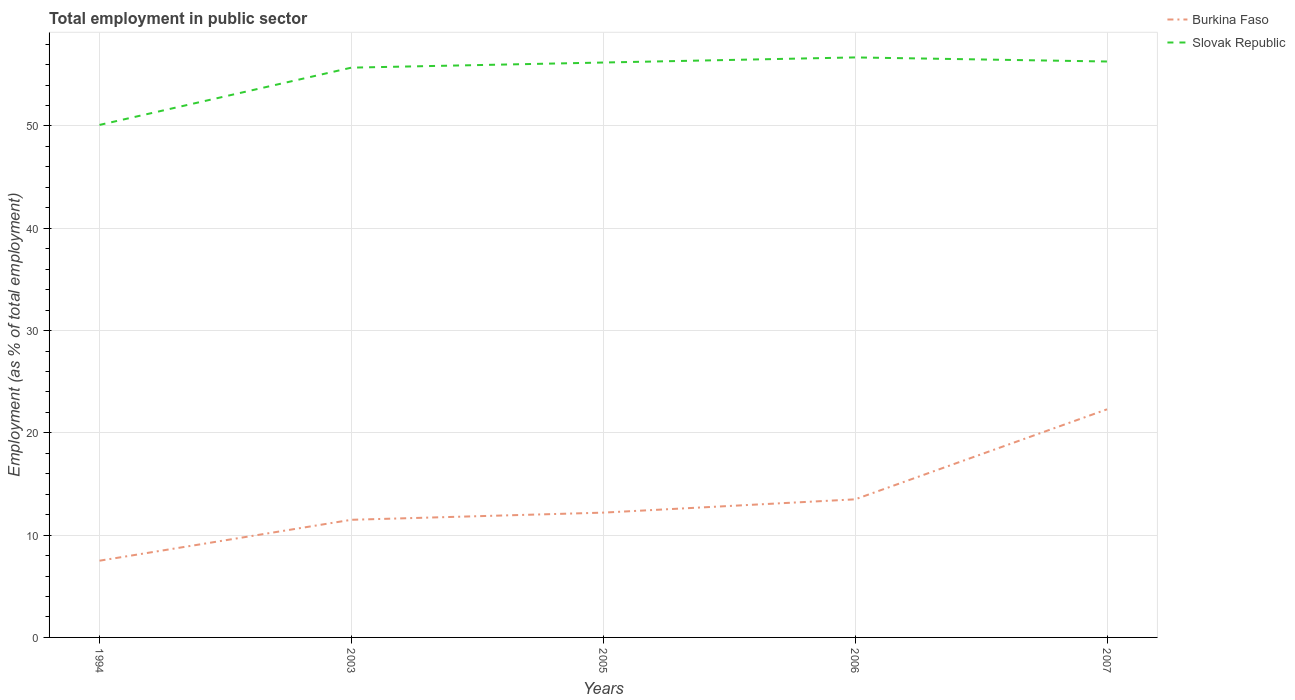Is the number of lines equal to the number of legend labels?
Your answer should be very brief. Yes. Across all years, what is the maximum employment in public sector in Burkina Faso?
Make the answer very short. 7.5. In which year was the employment in public sector in Slovak Republic maximum?
Your answer should be compact. 1994. What is the total employment in public sector in Slovak Republic in the graph?
Your answer should be compact. -0.5. What is the difference between the highest and the second highest employment in public sector in Slovak Republic?
Make the answer very short. 6.6. How many years are there in the graph?
Offer a very short reply. 5. What is the difference between two consecutive major ticks on the Y-axis?
Offer a terse response. 10. Does the graph contain any zero values?
Ensure brevity in your answer.  No. Where does the legend appear in the graph?
Your answer should be very brief. Top right. How many legend labels are there?
Make the answer very short. 2. How are the legend labels stacked?
Offer a terse response. Vertical. What is the title of the graph?
Your answer should be compact. Total employment in public sector. Does "Switzerland" appear as one of the legend labels in the graph?
Ensure brevity in your answer.  No. What is the label or title of the Y-axis?
Offer a terse response. Employment (as % of total employment). What is the Employment (as % of total employment) in Slovak Republic in 1994?
Keep it short and to the point. 50.1. What is the Employment (as % of total employment) of Slovak Republic in 2003?
Give a very brief answer. 55.7. What is the Employment (as % of total employment) in Burkina Faso in 2005?
Provide a succinct answer. 12.2. What is the Employment (as % of total employment) of Slovak Republic in 2005?
Offer a terse response. 56.2. What is the Employment (as % of total employment) in Burkina Faso in 2006?
Your response must be concise. 13.5. What is the Employment (as % of total employment) of Slovak Republic in 2006?
Give a very brief answer. 56.7. What is the Employment (as % of total employment) in Burkina Faso in 2007?
Offer a terse response. 22.3. What is the Employment (as % of total employment) in Slovak Republic in 2007?
Ensure brevity in your answer.  56.3. Across all years, what is the maximum Employment (as % of total employment) in Burkina Faso?
Give a very brief answer. 22.3. Across all years, what is the maximum Employment (as % of total employment) in Slovak Republic?
Make the answer very short. 56.7. Across all years, what is the minimum Employment (as % of total employment) of Burkina Faso?
Provide a succinct answer. 7.5. Across all years, what is the minimum Employment (as % of total employment) in Slovak Republic?
Your response must be concise. 50.1. What is the total Employment (as % of total employment) of Burkina Faso in the graph?
Make the answer very short. 67. What is the total Employment (as % of total employment) in Slovak Republic in the graph?
Provide a succinct answer. 275. What is the difference between the Employment (as % of total employment) in Burkina Faso in 1994 and that in 2003?
Offer a very short reply. -4. What is the difference between the Employment (as % of total employment) of Slovak Republic in 1994 and that in 2003?
Ensure brevity in your answer.  -5.6. What is the difference between the Employment (as % of total employment) of Burkina Faso in 1994 and that in 2006?
Make the answer very short. -6. What is the difference between the Employment (as % of total employment) of Slovak Republic in 1994 and that in 2006?
Make the answer very short. -6.6. What is the difference between the Employment (as % of total employment) in Burkina Faso in 1994 and that in 2007?
Provide a short and direct response. -14.8. What is the difference between the Employment (as % of total employment) of Burkina Faso in 2003 and that in 2006?
Give a very brief answer. -2. What is the difference between the Employment (as % of total employment) of Slovak Republic in 2003 and that in 2006?
Ensure brevity in your answer.  -1. What is the difference between the Employment (as % of total employment) of Burkina Faso in 2005 and that in 2007?
Offer a terse response. -10.1. What is the difference between the Employment (as % of total employment) in Slovak Republic in 2005 and that in 2007?
Give a very brief answer. -0.1. What is the difference between the Employment (as % of total employment) of Slovak Republic in 2006 and that in 2007?
Keep it short and to the point. 0.4. What is the difference between the Employment (as % of total employment) of Burkina Faso in 1994 and the Employment (as % of total employment) of Slovak Republic in 2003?
Your response must be concise. -48.2. What is the difference between the Employment (as % of total employment) of Burkina Faso in 1994 and the Employment (as % of total employment) of Slovak Republic in 2005?
Your answer should be very brief. -48.7. What is the difference between the Employment (as % of total employment) in Burkina Faso in 1994 and the Employment (as % of total employment) in Slovak Republic in 2006?
Your answer should be compact. -49.2. What is the difference between the Employment (as % of total employment) of Burkina Faso in 1994 and the Employment (as % of total employment) of Slovak Republic in 2007?
Your response must be concise. -48.8. What is the difference between the Employment (as % of total employment) of Burkina Faso in 2003 and the Employment (as % of total employment) of Slovak Republic in 2005?
Offer a very short reply. -44.7. What is the difference between the Employment (as % of total employment) in Burkina Faso in 2003 and the Employment (as % of total employment) in Slovak Republic in 2006?
Your answer should be very brief. -45.2. What is the difference between the Employment (as % of total employment) in Burkina Faso in 2003 and the Employment (as % of total employment) in Slovak Republic in 2007?
Provide a succinct answer. -44.8. What is the difference between the Employment (as % of total employment) in Burkina Faso in 2005 and the Employment (as % of total employment) in Slovak Republic in 2006?
Keep it short and to the point. -44.5. What is the difference between the Employment (as % of total employment) in Burkina Faso in 2005 and the Employment (as % of total employment) in Slovak Republic in 2007?
Provide a succinct answer. -44.1. What is the difference between the Employment (as % of total employment) of Burkina Faso in 2006 and the Employment (as % of total employment) of Slovak Republic in 2007?
Ensure brevity in your answer.  -42.8. What is the average Employment (as % of total employment) of Burkina Faso per year?
Provide a succinct answer. 13.4. In the year 1994, what is the difference between the Employment (as % of total employment) of Burkina Faso and Employment (as % of total employment) of Slovak Republic?
Provide a short and direct response. -42.6. In the year 2003, what is the difference between the Employment (as % of total employment) of Burkina Faso and Employment (as % of total employment) of Slovak Republic?
Provide a short and direct response. -44.2. In the year 2005, what is the difference between the Employment (as % of total employment) of Burkina Faso and Employment (as % of total employment) of Slovak Republic?
Make the answer very short. -44. In the year 2006, what is the difference between the Employment (as % of total employment) of Burkina Faso and Employment (as % of total employment) of Slovak Republic?
Offer a very short reply. -43.2. In the year 2007, what is the difference between the Employment (as % of total employment) of Burkina Faso and Employment (as % of total employment) of Slovak Republic?
Give a very brief answer. -34. What is the ratio of the Employment (as % of total employment) of Burkina Faso in 1994 to that in 2003?
Give a very brief answer. 0.65. What is the ratio of the Employment (as % of total employment) of Slovak Republic in 1994 to that in 2003?
Keep it short and to the point. 0.9. What is the ratio of the Employment (as % of total employment) in Burkina Faso in 1994 to that in 2005?
Keep it short and to the point. 0.61. What is the ratio of the Employment (as % of total employment) of Slovak Republic in 1994 to that in 2005?
Keep it short and to the point. 0.89. What is the ratio of the Employment (as % of total employment) in Burkina Faso in 1994 to that in 2006?
Give a very brief answer. 0.56. What is the ratio of the Employment (as % of total employment) of Slovak Republic in 1994 to that in 2006?
Your answer should be very brief. 0.88. What is the ratio of the Employment (as % of total employment) of Burkina Faso in 1994 to that in 2007?
Make the answer very short. 0.34. What is the ratio of the Employment (as % of total employment) in Slovak Republic in 1994 to that in 2007?
Make the answer very short. 0.89. What is the ratio of the Employment (as % of total employment) of Burkina Faso in 2003 to that in 2005?
Keep it short and to the point. 0.94. What is the ratio of the Employment (as % of total employment) of Burkina Faso in 2003 to that in 2006?
Offer a very short reply. 0.85. What is the ratio of the Employment (as % of total employment) in Slovak Republic in 2003 to that in 2006?
Offer a terse response. 0.98. What is the ratio of the Employment (as % of total employment) in Burkina Faso in 2003 to that in 2007?
Offer a very short reply. 0.52. What is the ratio of the Employment (as % of total employment) of Slovak Republic in 2003 to that in 2007?
Your answer should be very brief. 0.99. What is the ratio of the Employment (as % of total employment) of Burkina Faso in 2005 to that in 2006?
Offer a very short reply. 0.9. What is the ratio of the Employment (as % of total employment) of Burkina Faso in 2005 to that in 2007?
Your answer should be very brief. 0.55. What is the ratio of the Employment (as % of total employment) in Slovak Republic in 2005 to that in 2007?
Provide a short and direct response. 1. What is the ratio of the Employment (as % of total employment) in Burkina Faso in 2006 to that in 2007?
Give a very brief answer. 0.61. What is the ratio of the Employment (as % of total employment) of Slovak Republic in 2006 to that in 2007?
Your answer should be compact. 1.01. What is the difference between the highest and the second highest Employment (as % of total employment) in Burkina Faso?
Your answer should be compact. 8.8. What is the difference between the highest and the lowest Employment (as % of total employment) of Slovak Republic?
Your answer should be compact. 6.6. 